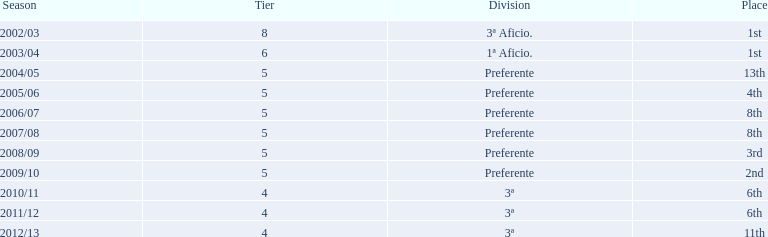Which seasons were played in tier four? 2010/11, 2011/12, 2012/13. Of these seasons, which resulted in 6th place? 2010/11, 2011/12. Which of the remaining happened last? 2011/12. 